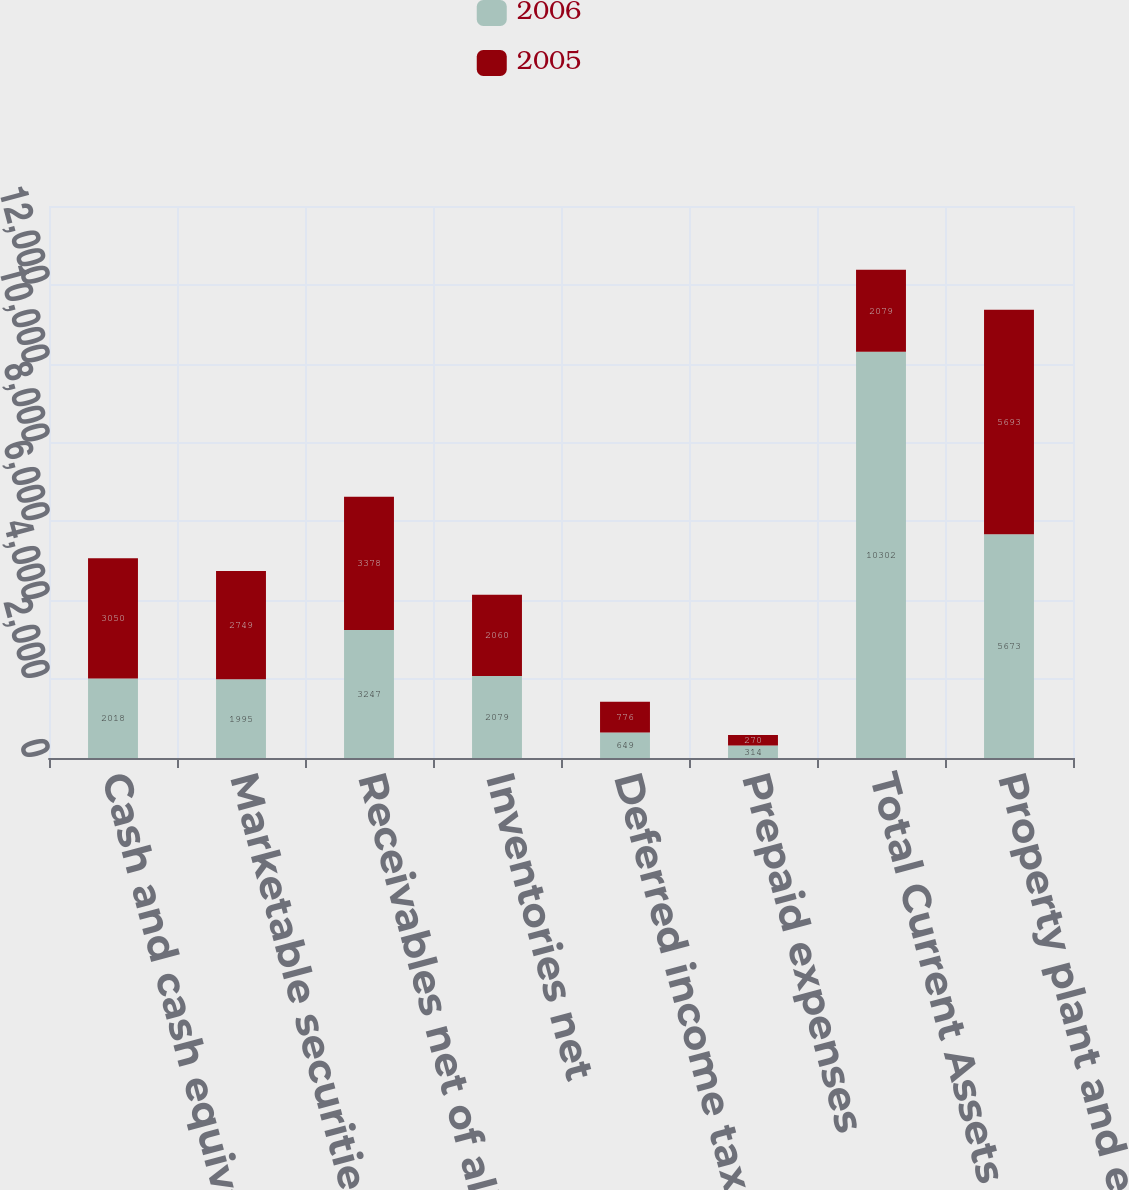Convert chart. <chart><loc_0><loc_0><loc_500><loc_500><stacked_bar_chart><ecel><fcel>Cash and cash equivalents<fcel>Marketable securities<fcel>Receivables net of allowances<fcel>Inventories net<fcel>Deferred income taxes net of<fcel>Prepaid expenses<fcel>Total Current Assets<fcel>Property plant and equipment<nl><fcel>2006<fcel>2018<fcel>1995<fcel>3247<fcel>2079<fcel>649<fcel>314<fcel>10302<fcel>5673<nl><fcel>2005<fcel>3050<fcel>2749<fcel>3378<fcel>2060<fcel>776<fcel>270<fcel>2079<fcel>5693<nl></chart> 